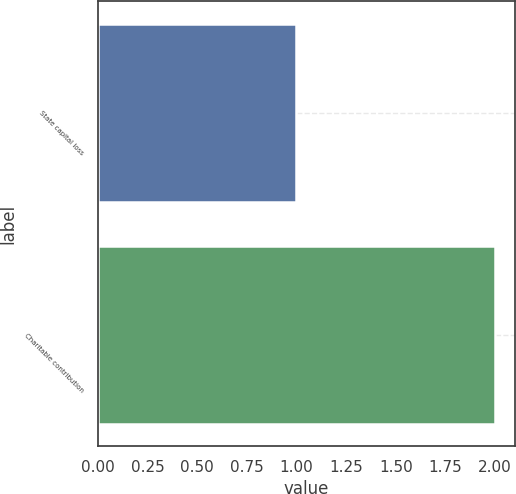Convert chart. <chart><loc_0><loc_0><loc_500><loc_500><bar_chart><fcel>State capital loss<fcel>Charitable contribution<nl><fcel>1<fcel>2<nl></chart> 